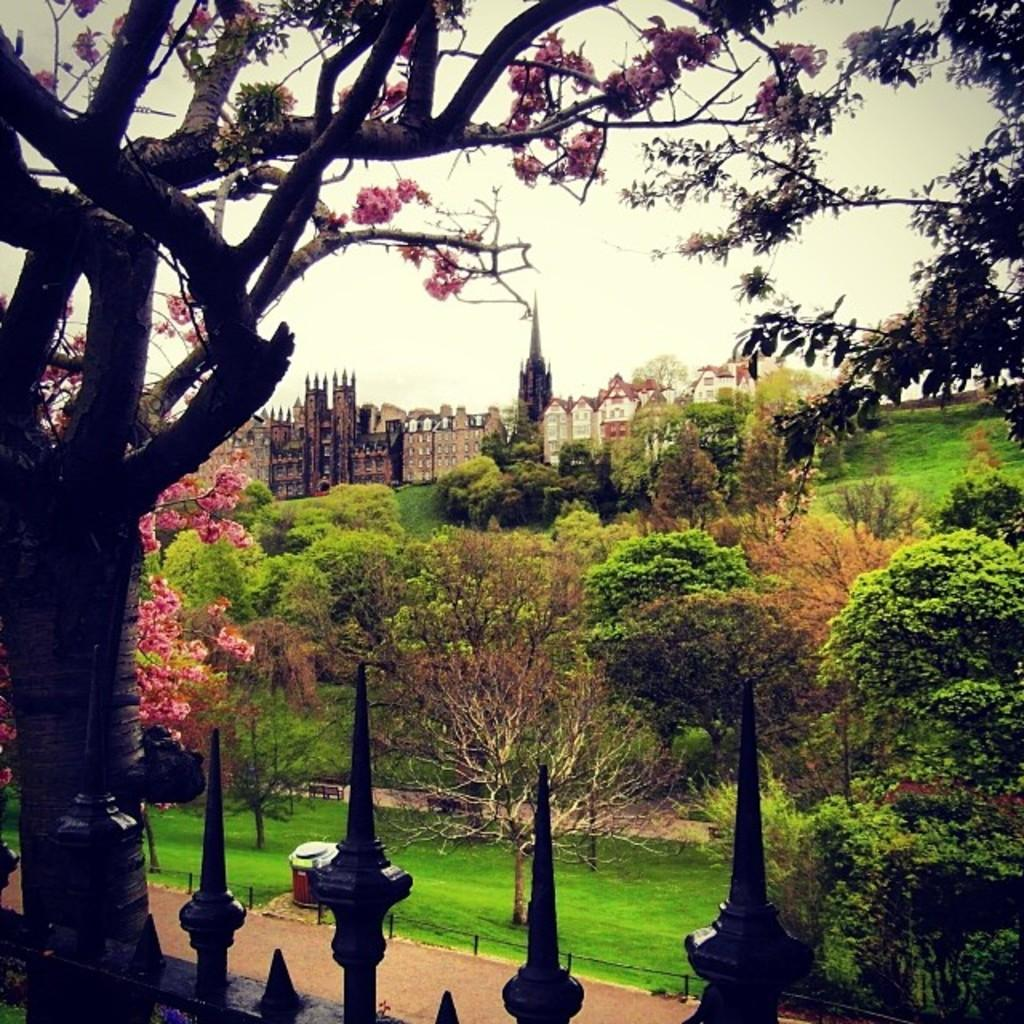What type of structures can be seen in the image? There are buildings and houses with roofs in the image. What kind of vegetation is present in the image? There is a group of trees with flowers in the image, and grass is also present. Can you describe a specific detail about one of the trees? A bark of a tree is visible in the image. What is the ground surface like in the image? There is a pathway in the image. How would you describe the sky in the image? The sky is visible in the image, and it looks cloudy. Where is the badge located in the image? There is no badge present in the image. What type of root can be seen growing from the tree in the image? There is no root visible in the image; only the bark of a tree is mentioned. --- Facts: 1. There is a person holding a book in the image. 2. The person is sitting on a chair. 3. The chair is made of wood. 4. There is a table next to the chair. 5. The table has a lamp on it. 6. The room has a window. 7. The window has curtains. Absurd Topics: parrot, sand, ocean Conversation: What is the person in the image holding? The person is holding a book in the image. Where is the person sitting? The person is sitting on a chair in the image. Can you describe the chair? The chair is made of wood. What is located next to the chair? There is a table next to the chair in the image. What is on the table? The table has a lamp on it. What can be seen outside the room through the window? The room has a window, but the facts do not specify what can be seen outside. Reasoning: Let's think step by step in order to produce the conversation. We start by identifying the main subject in the image, which is the person holding a book. Then, we expand the conversation to include other items that are also visible, such as the chair, table, and lamp. Each question is designed to elicit a specific detail about the image that is known from the provided facts. Absurd Question/Answer: Can you see a parrot sitting on the person's shoulder in the image? There is no parrot present in the image. What type of sand can be seen on the floor in the image? There is no sand present in the image; the floor is not mentioned in the facts. 